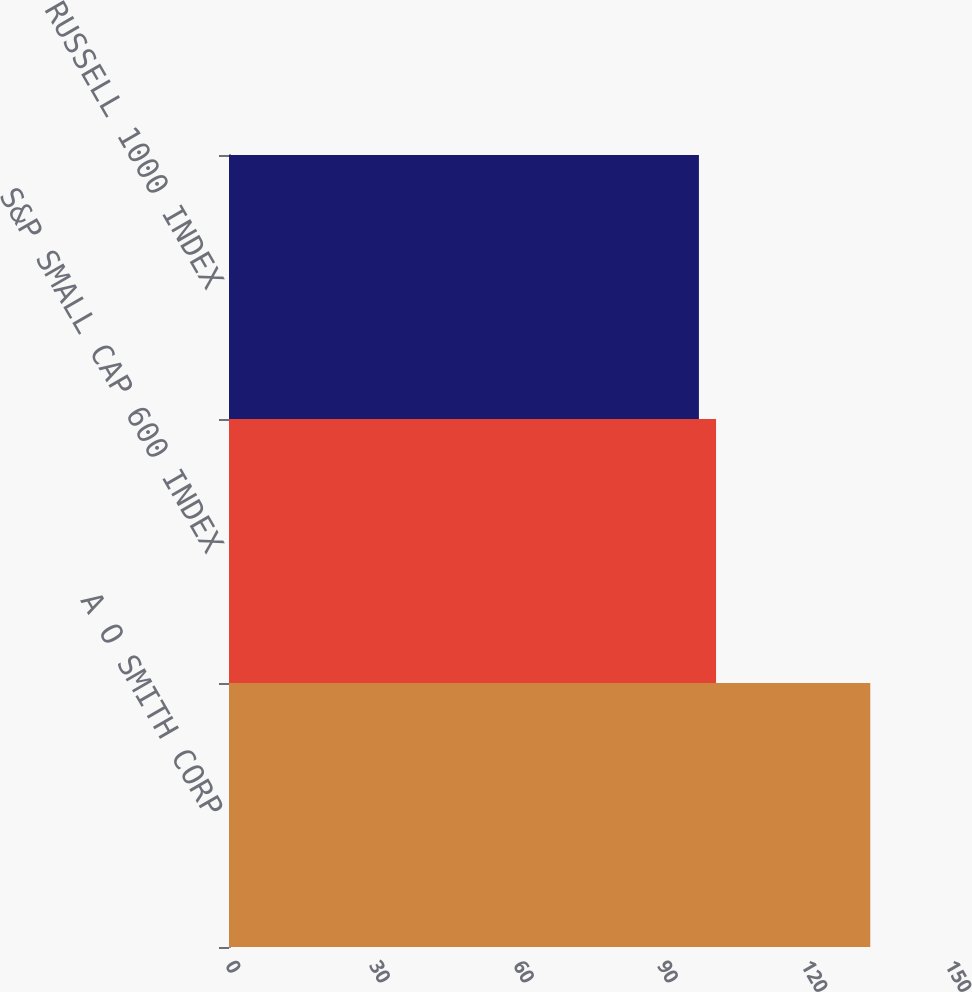<chart> <loc_0><loc_0><loc_500><loc_500><bar_chart><fcel>A O SMITH CORP<fcel>S&P SMALL CAP 600 INDEX<fcel>RUSSELL 1000 INDEX<nl><fcel>133.6<fcel>101.47<fcel>97.9<nl></chart> 